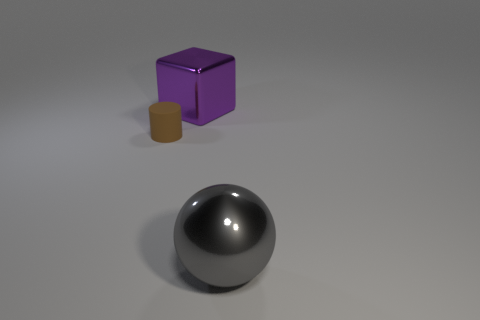There is a large object left of the object that is on the right side of the purple block; what color is it?
Make the answer very short. Purple. There is a metal object left of the large object in front of the big metallic object on the left side of the large gray shiny object; what is its size?
Your answer should be very brief. Large. What number of other objects are there of the same size as the brown matte cylinder?
Offer a very short reply. 0. There is a object behind the brown thing; what is its size?
Give a very brief answer. Large. What number of objects have the same material as the large purple cube?
Make the answer very short. 1. What shape is the gray thing in front of the purple thing?
Make the answer very short. Sphere. What is the material of the big gray sphere?
Provide a succinct answer. Metal. The metal sphere that is the same size as the purple metal thing is what color?
Provide a succinct answer. Gray. Is the rubber object the same shape as the gray object?
Ensure brevity in your answer.  No. The thing that is both right of the brown cylinder and to the left of the gray metal object is made of what material?
Provide a short and direct response. Metal. 